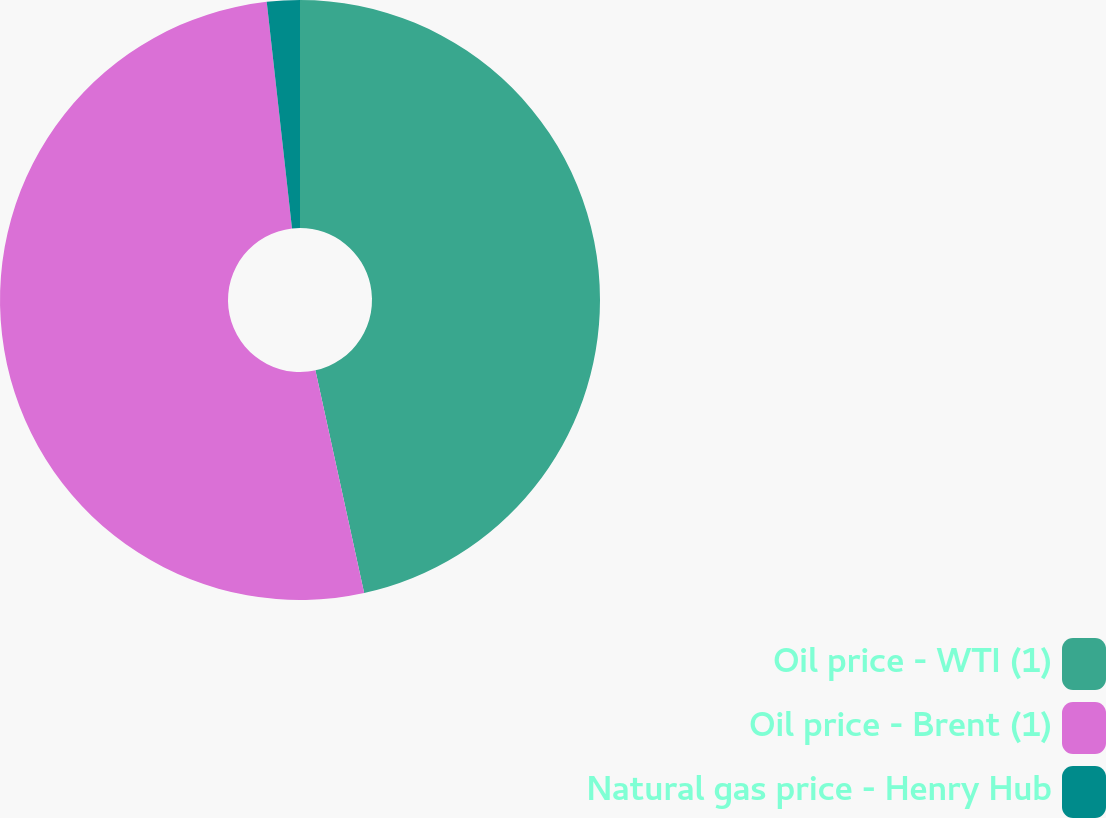Convert chart to OTSL. <chart><loc_0><loc_0><loc_500><loc_500><pie_chart><fcel>Oil price - WTI (1)<fcel>Oil price - Brent (1)<fcel>Natural gas price - Henry Hub<nl><fcel>46.57%<fcel>51.66%<fcel>1.77%<nl></chart> 